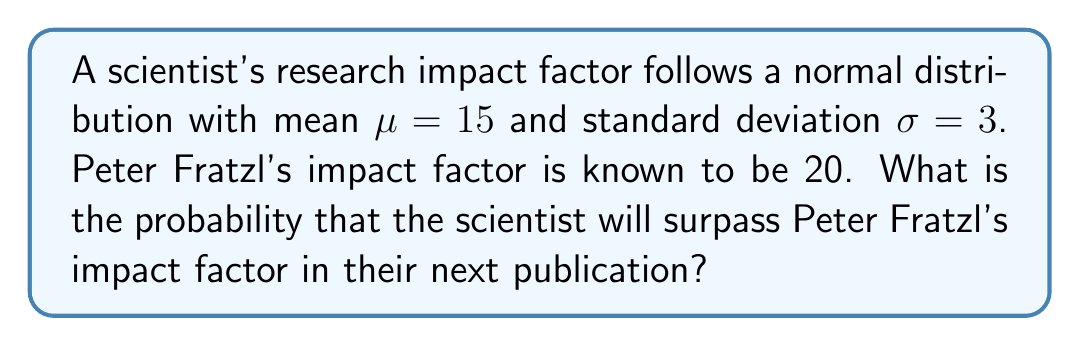Solve this math problem. To solve this problem, we need to follow these steps:

1) First, we need to calculate the z-score for Peter Fratzl's impact factor. The z-score tells us how many standard deviations above or below the mean a value is. The formula for z-score is:

   $$z = \frac{x - \mu}{\sigma}$$

   Where $x$ is the value (Peter's impact factor), $\mu$ is the mean, and $\sigma$ is the standard deviation.

2) Plugging in the values:

   $$z = \frac{20 - 15}{3} = \frac{5}{3} \approx 1.67$$

3) Now, we want to find the probability of the scientist's impact factor being greater than 20, which is equivalent to finding the area under the standard normal curve to the right of z = 1.67.

4) This is a right-tailed test, so we need to find:

   $$P(Z > 1.67)$$

5) Using a standard normal distribution table or calculator, we can find that:

   $$P(Z > 1.67) \approx 0.0475$$

6) Therefore, the probability of surpassing Peter Fratzl's impact factor is approximately 0.0475 or 4.75%.
Answer: 0.0475 